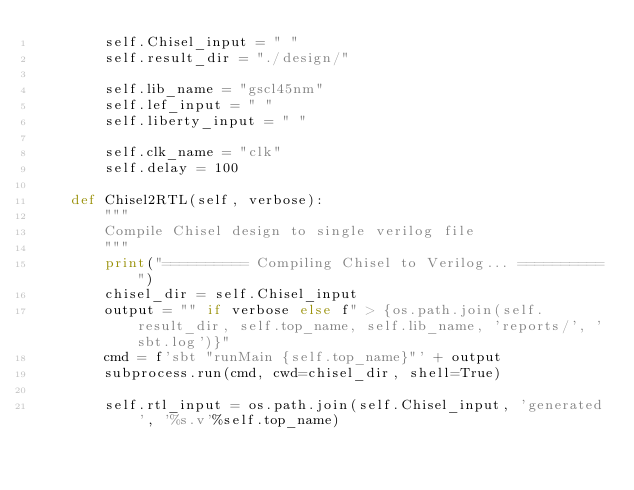Convert code to text. <code><loc_0><loc_0><loc_500><loc_500><_Python_>        self.Chisel_input = " "
        self.result_dir = "./design/"

        self.lib_name = "gscl45nm"
        self.lef_input = " "
        self.liberty_input = " "

        self.clk_name = "clk"
        self.delay = 100

    def Chisel2RTL(self, verbose):
        """
        Compile Chisel design to single verilog file
        """
        print("========== Compiling Chisel to Verilog... ==========")
        chisel_dir = self.Chisel_input
        output = "" if verbose else f" > {os.path.join(self.result_dir, self.top_name, self.lib_name, 'reports/', 'sbt.log')}"
        cmd = f'sbt "runMain {self.top_name}"' + output
        subprocess.run(cmd, cwd=chisel_dir, shell=True)
    
        self.rtl_input = os.path.join(self.Chisel_input, 'generated', '%s.v'%self.top_name)

</code> 